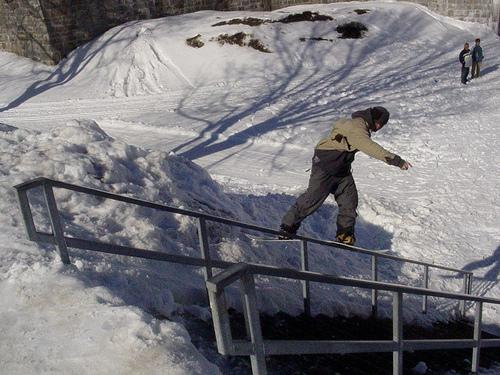Question: what is the boy doing?
Choices:
A. Skateboarding.
B. Riding a bike.
C. Skiing.
D. Playing soccer.
Answer with the letter. Answer: A Question: how is the weather?
Choices:
A. Rainy.
B. Foggy.
C. Clear.
D. Sunny.
Answer with the letter. Answer: C Question: who is in the picture?
Choices:
A. A girl.
B. A boy.
C. A horse.
D. A dog.
Answer with the letter. Answer: B Question: what color is the boy's jacket?
Choices:
A. Black.
B. Blue.
C. Grey.
D. Brown.
Answer with the letter. Answer: D Question: where was this picture taken?
Choices:
A. A restaurant.
B. A beach.
C. A park.
D. A ski resort.
Answer with the letter. Answer: C Question: what is the boy standing on?
Choices:
A. A table.
B. A railing.
C. A chair.
D. Steps.
Answer with the letter. Answer: B 